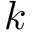<formula> <loc_0><loc_0><loc_500><loc_500>k</formula> 